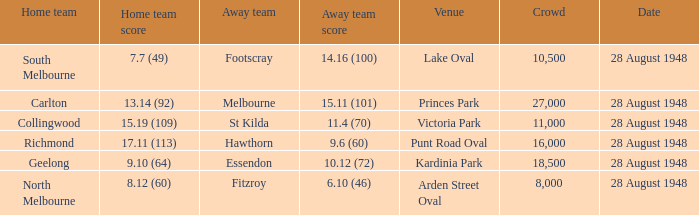What home team has a team score of 8.12 (60)? North Melbourne. 